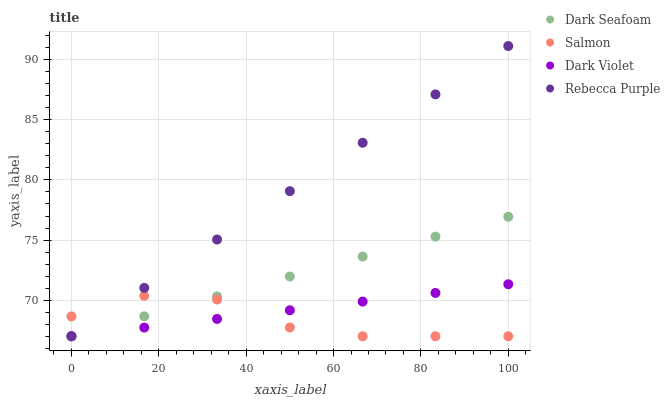Does Salmon have the minimum area under the curve?
Answer yes or no. Yes. Does Rebecca Purple have the maximum area under the curve?
Answer yes or no. Yes. Does Rebecca Purple have the minimum area under the curve?
Answer yes or no. No. Does Salmon have the maximum area under the curve?
Answer yes or no. No. Is Dark Violet the smoothest?
Answer yes or no. Yes. Is Salmon the roughest?
Answer yes or no. Yes. Is Rebecca Purple the smoothest?
Answer yes or no. No. Is Rebecca Purple the roughest?
Answer yes or no. No. Does Dark Seafoam have the lowest value?
Answer yes or no. Yes. Does Rebecca Purple have the highest value?
Answer yes or no. Yes. Does Salmon have the highest value?
Answer yes or no. No. Does Salmon intersect Dark Seafoam?
Answer yes or no. Yes. Is Salmon less than Dark Seafoam?
Answer yes or no. No. Is Salmon greater than Dark Seafoam?
Answer yes or no. No. 